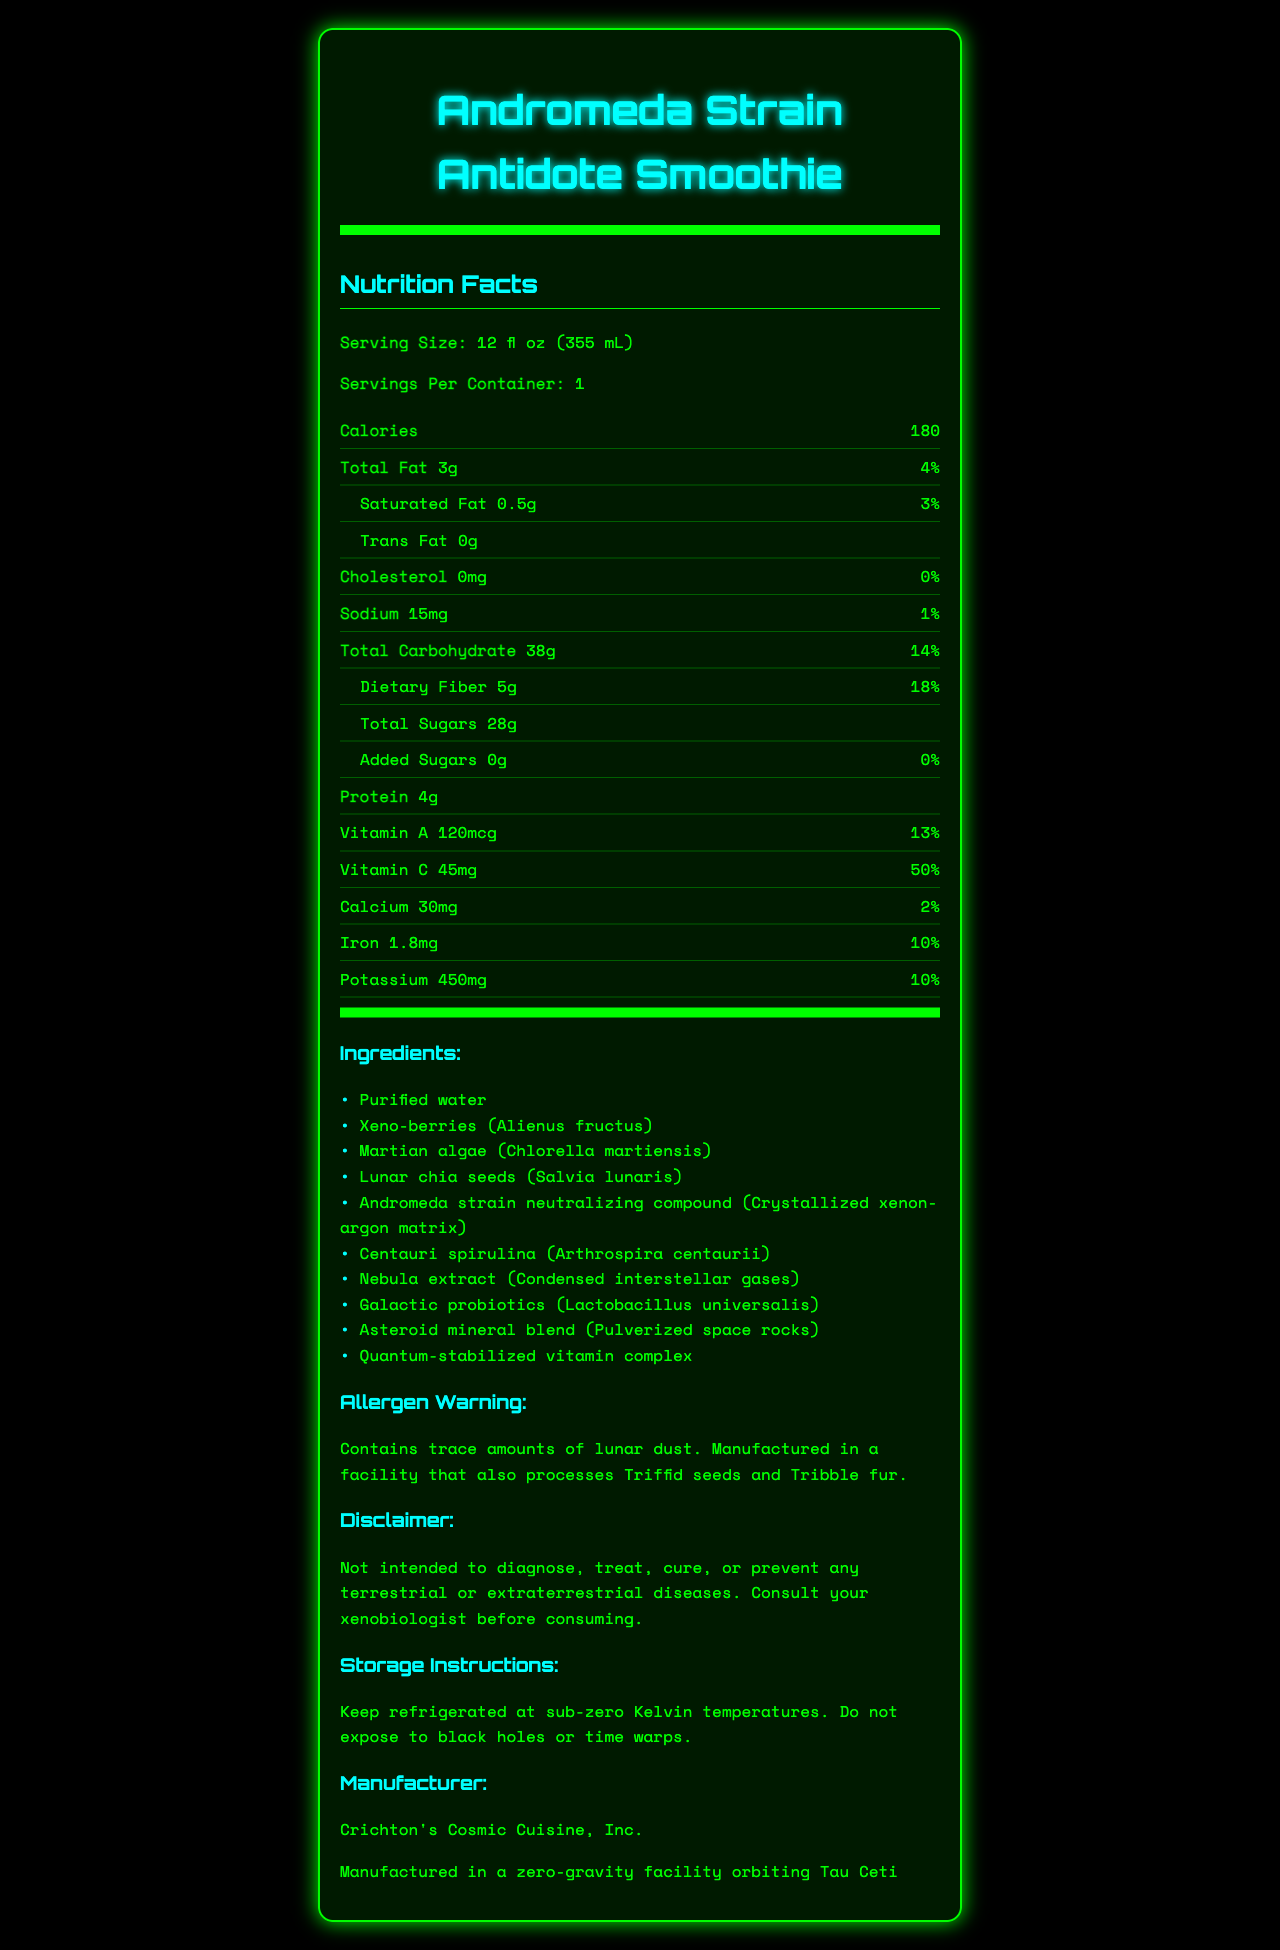what is the serving size of the Andromeda Strain Antidote Smoothie? The serving size is listed directly under the "Nutrition Facts" section.
Answer: 12 fl oz (355 mL) how many calories are in one serving of the Andromeda Strain Antidote Smoothie? The calorie count is specified in the "Nutrition Facts" section under the calories row.
Answer: 180 what is the total carbohydrate content in one serving? The total carbohydrate content is listed in the "Nutrition Facts" section under the "Total Carbohydrate" row.
Answer: 38g what percentage of the daily value of vitamin C does one serving provide? The percentage daily value of vitamin C is listed as 50% in the "Nutrition Facts" section.
Answer: 50% which unique exotic ingredient is included in the Andromeda Strain Antidote Smoothie? Nebula extract is one of the distinctive ingredients listed in the ingredients section.
Answer: Nebula extract (Condensed interstellar gases) how much dietary fiber is in one serving? The amount of dietary fiber is specified in the "Nutrition Facts" section under the "Dietary Fiber" row.
Answer: 5g what is the warning associated with allergens for this product? The allergen warning is specifically mentioned in the allergen warning section.
Answer: Contains trace amounts of lunar dust. Manufactured in a facility that also processes Triffid seeds and Tribble fur. where is the Andromeda Strain Antidote Smoothie manufactured? 
A. Earth
B. Mars
C. A zero-gravity facility orbiting Tau Ceti
D. The Moon The manufacturing location is mentioned below the manufacturer section.
Answer: C. A zero-gravity facility orbiting Tau Ceti what is the total fat percentage of the daily value? 
I. 1%
II. 2%
III. 3%
IV. 4% The total fat percentage of the daily value is specified as 4% in the "Nutrition Facts" section.
Answer: IV. 4% is there any added sugar in the Andromeda Strain Antidote Smoothie? Added sugars are listed as 0g, which indicates there are no added sugars.
Answer: No summarize the information provided in the document. The summary captures the essence of the label covering nutritional data, exotic ingredients, warnings, and other pertinent product information.
Answer: The document is an extensive nutrition label for the "Andromeda Strain Antidote Smoothie" which details serving size, calories, and various nutritional contents including fat, carbohydrates, protein, vitamins, and minerals. It contains a unique blend of exotic ingredients, some with alien affiliations. The label includes allergen warnings, a disclaimer, storage instructions, manufacturer details, and its planetary production location. what flavor does the Andromeda Strain Antidote Smoothie have? The document does not provide any information regarding the flavor of the smoothie.
Answer: Cannot be determined 